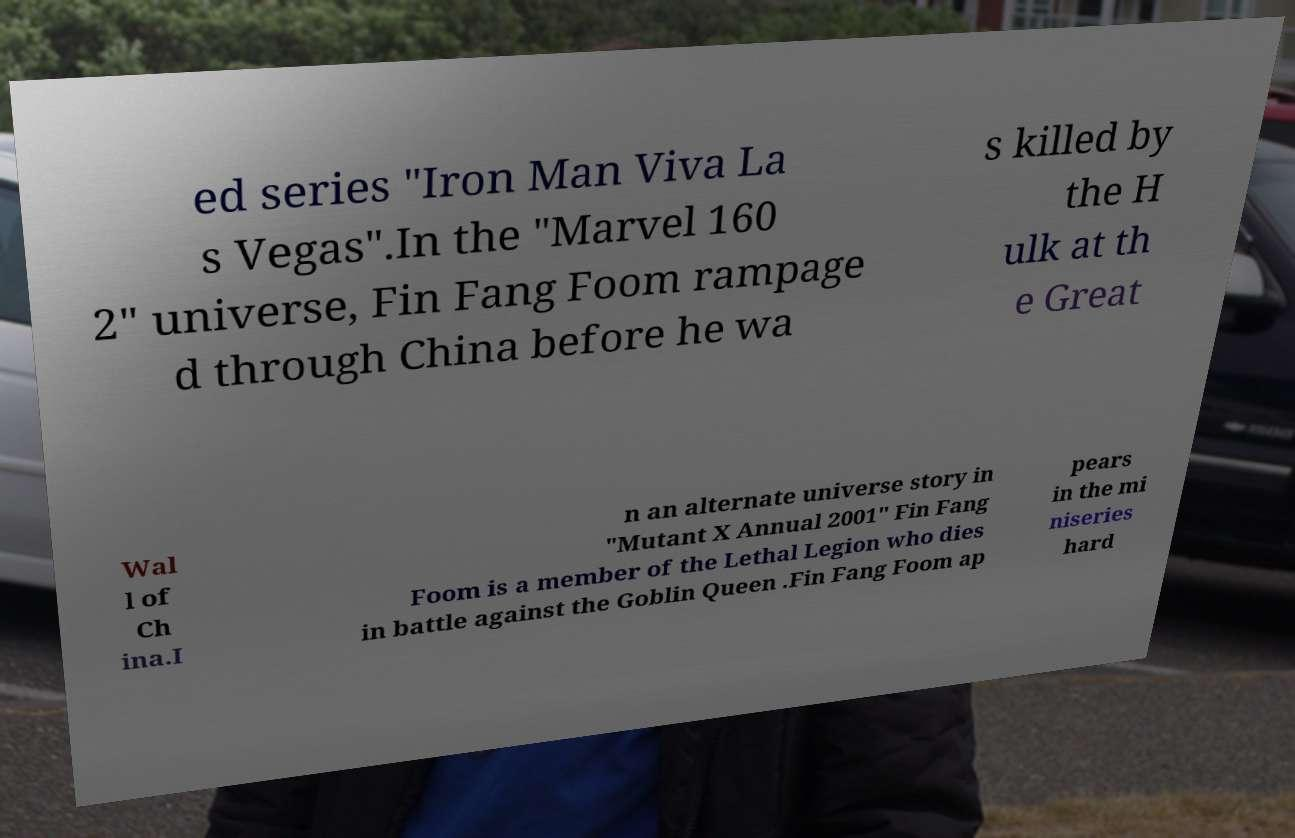Please read and relay the text visible in this image. What does it say? ed series "Iron Man Viva La s Vegas".In the "Marvel 160 2" universe, Fin Fang Foom rampage d through China before he wa s killed by the H ulk at th e Great Wal l of Ch ina.I n an alternate universe story in "Mutant X Annual 2001" Fin Fang Foom is a member of the Lethal Legion who dies in battle against the Goblin Queen .Fin Fang Foom ap pears in the mi niseries hard 